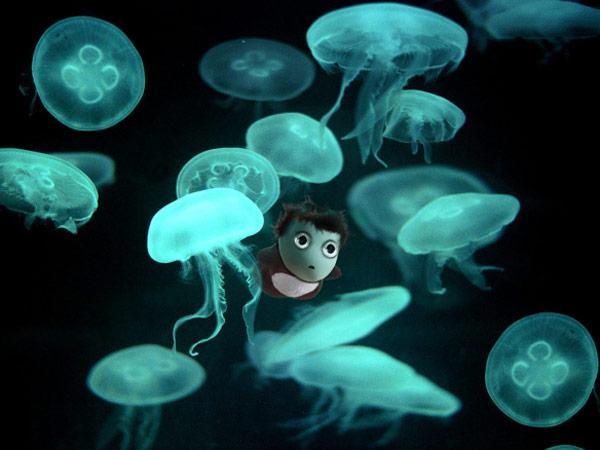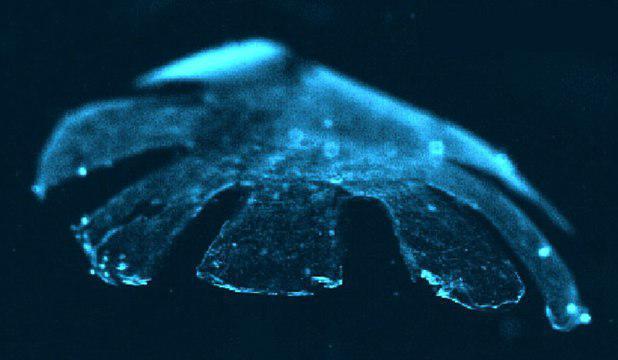The first image is the image on the left, the second image is the image on the right. Evaluate the accuracy of this statement regarding the images: "There are no more than 5 jellyfish in the image on the right.". Is it true? Answer yes or no. Yes. 